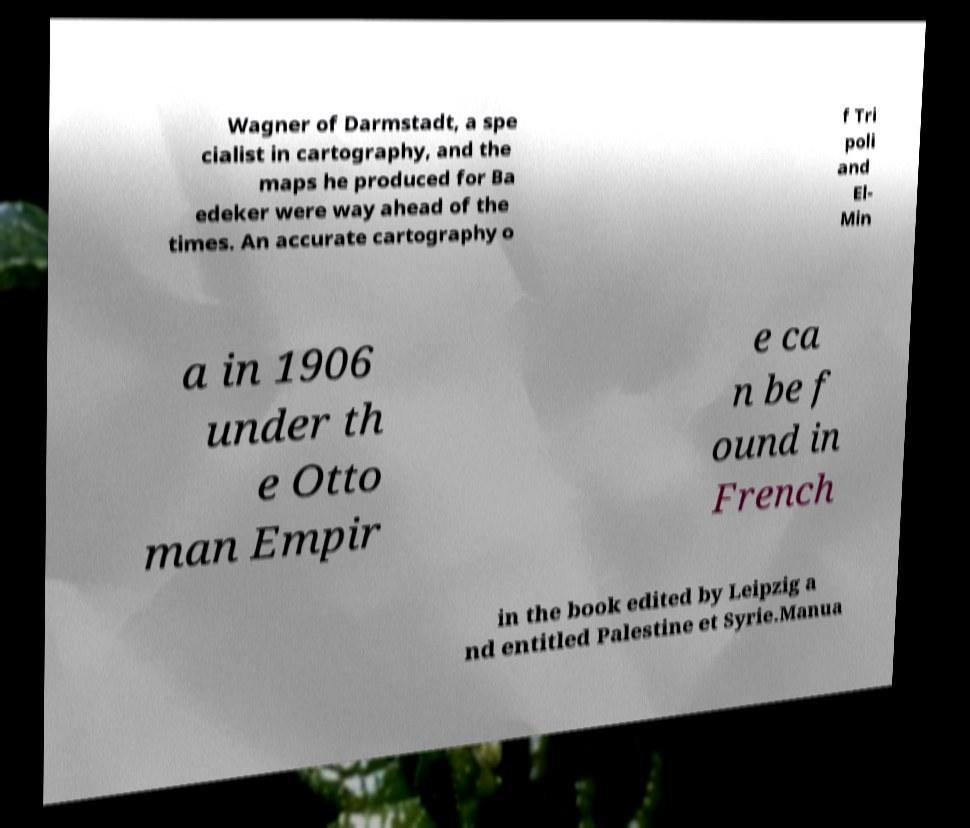Please identify and transcribe the text found in this image. Wagner of Darmstadt, a spe cialist in cartography, and the maps he produced for Ba edeker were way ahead of the times. An accurate cartography o f Tri poli and El- Min a in 1906 under th e Otto man Empir e ca n be f ound in French in the book edited by Leipzig a nd entitled Palestine et Syrie.Manua 